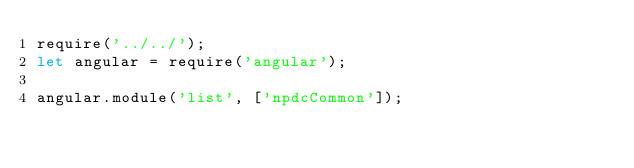Convert code to text. <code><loc_0><loc_0><loc_500><loc_500><_JavaScript_>require('../../');
let angular = require('angular');

angular.module('list', ['npdcCommon']);
</code> 